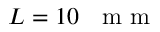<formula> <loc_0><loc_0><loc_500><loc_500>L = 1 0 m m</formula> 